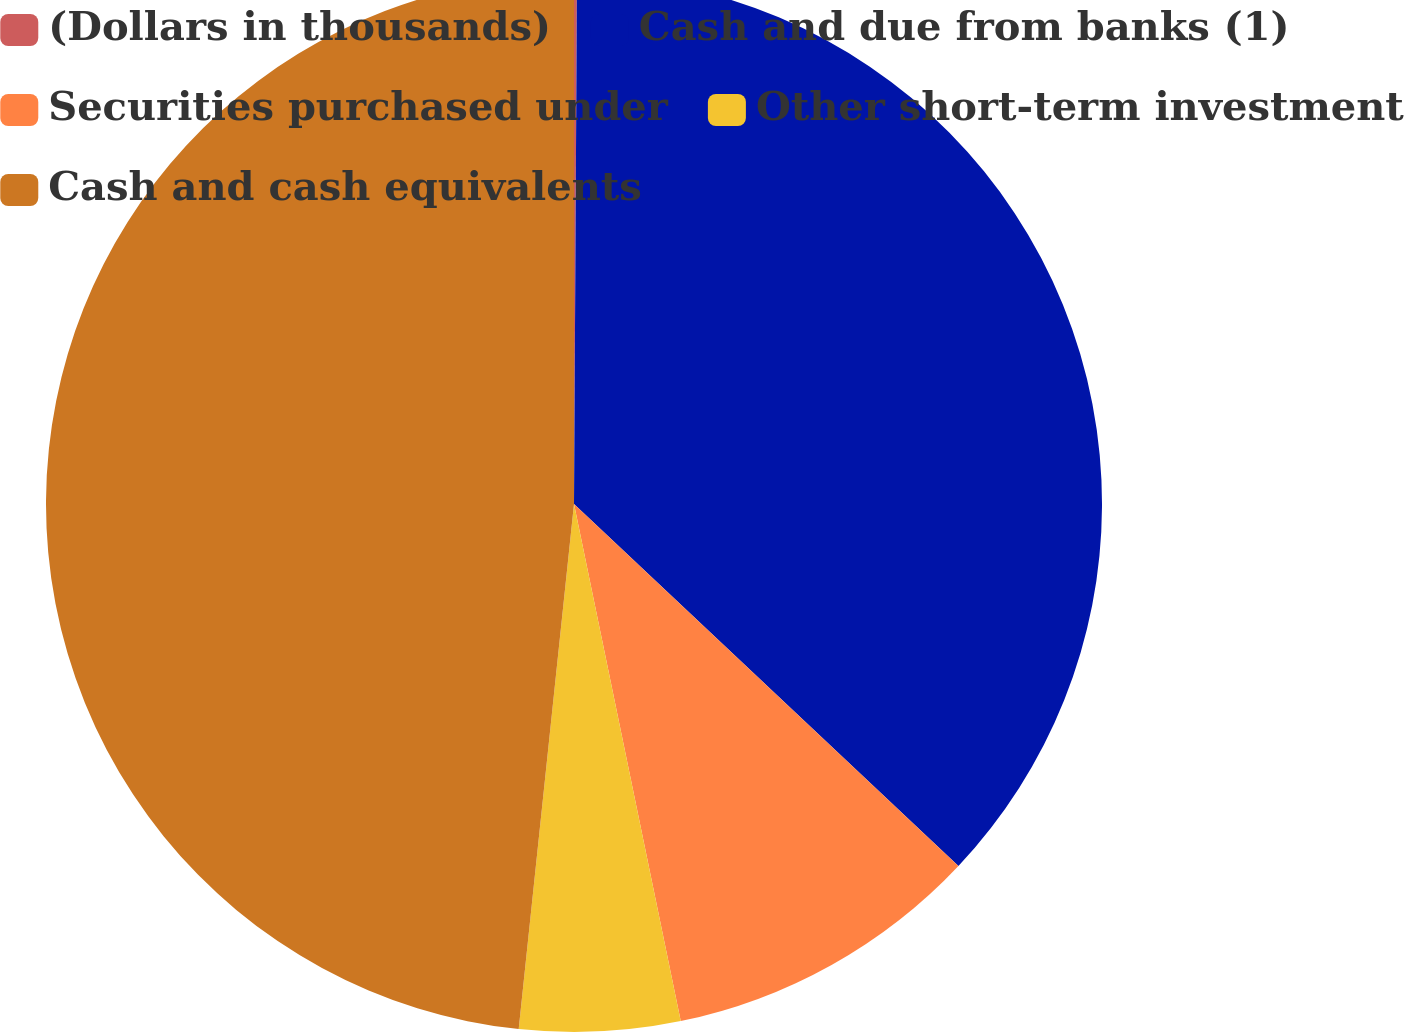Convert chart. <chart><loc_0><loc_0><loc_500><loc_500><pie_chart><fcel>(Dollars in thousands)<fcel>Cash and due from banks (1)<fcel>Securities purchased under<fcel>Other short-term investment<fcel>Cash and cash equivalents<nl><fcel>0.09%<fcel>36.93%<fcel>9.74%<fcel>4.91%<fcel>48.33%<nl></chart> 